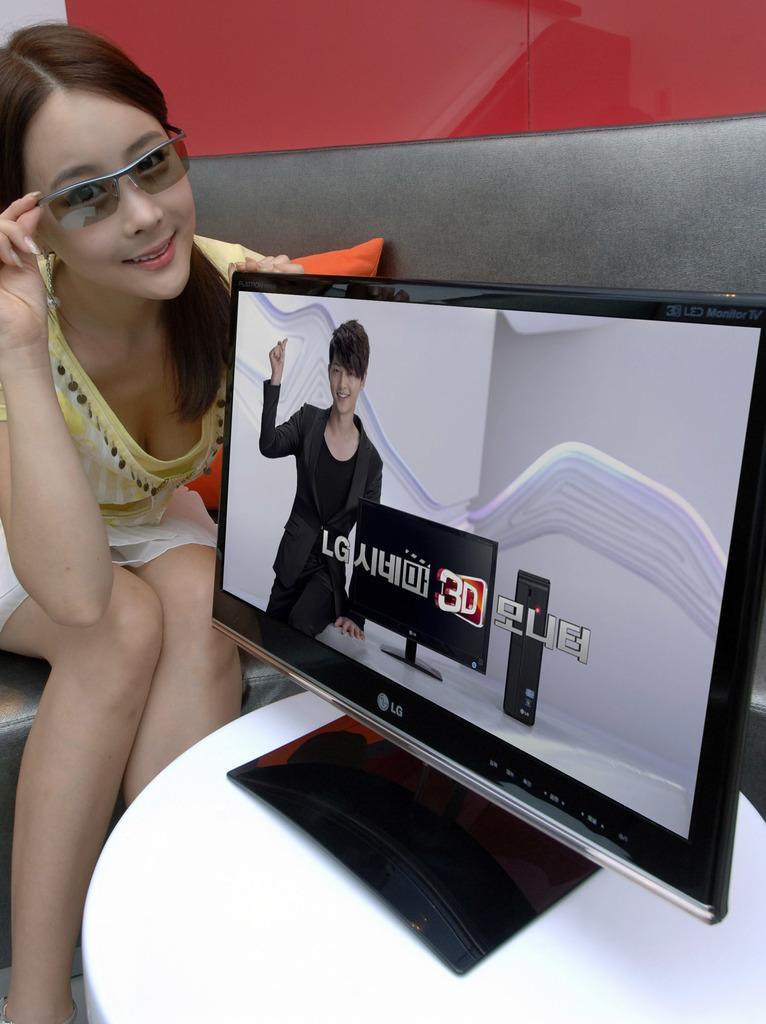Describe this image in one or two sentences. This woman is sitting and wore goggles. On this table there is a television. On this television screen we can see a person, monitor and CPU. Something written on this screen. Background there is a red wall. 